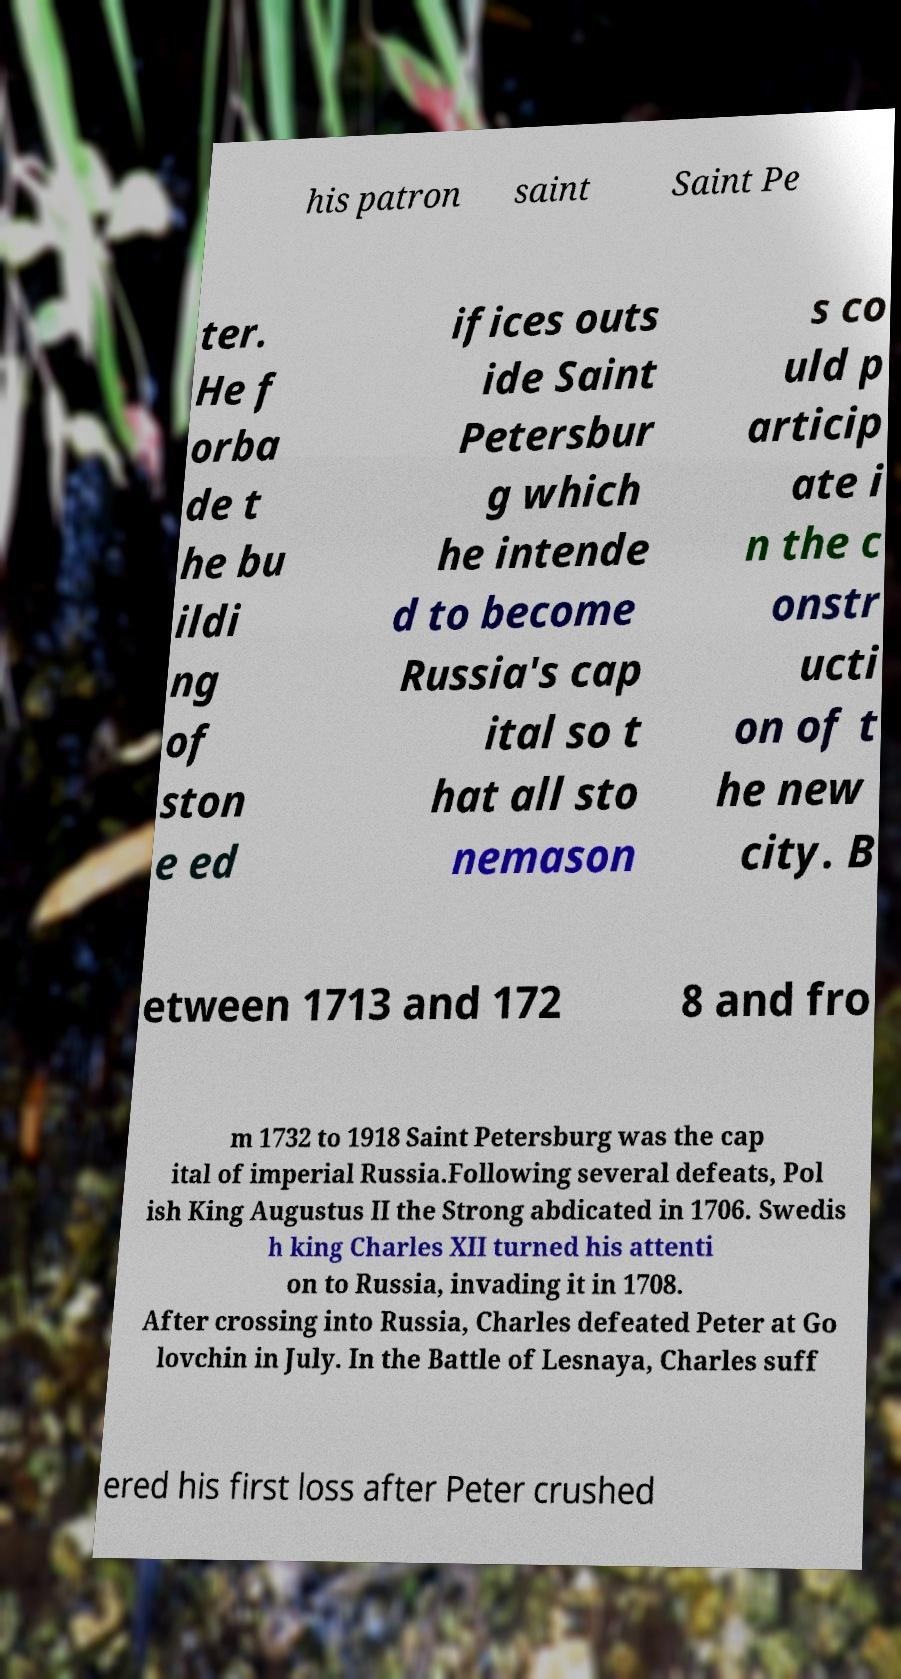Could you extract and type out the text from this image? his patron saint Saint Pe ter. He f orba de t he bu ildi ng of ston e ed ifices outs ide Saint Petersbur g which he intende d to become Russia's cap ital so t hat all sto nemason s co uld p articip ate i n the c onstr ucti on of t he new city. B etween 1713 and 172 8 and fro m 1732 to 1918 Saint Petersburg was the cap ital of imperial Russia.Following several defeats, Pol ish King Augustus II the Strong abdicated in 1706. Swedis h king Charles XII turned his attenti on to Russia, invading it in 1708. After crossing into Russia, Charles defeated Peter at Go lovchin in July. In the Battle of Lesnaya, Charles suff ered his first loss after Peter crushed 